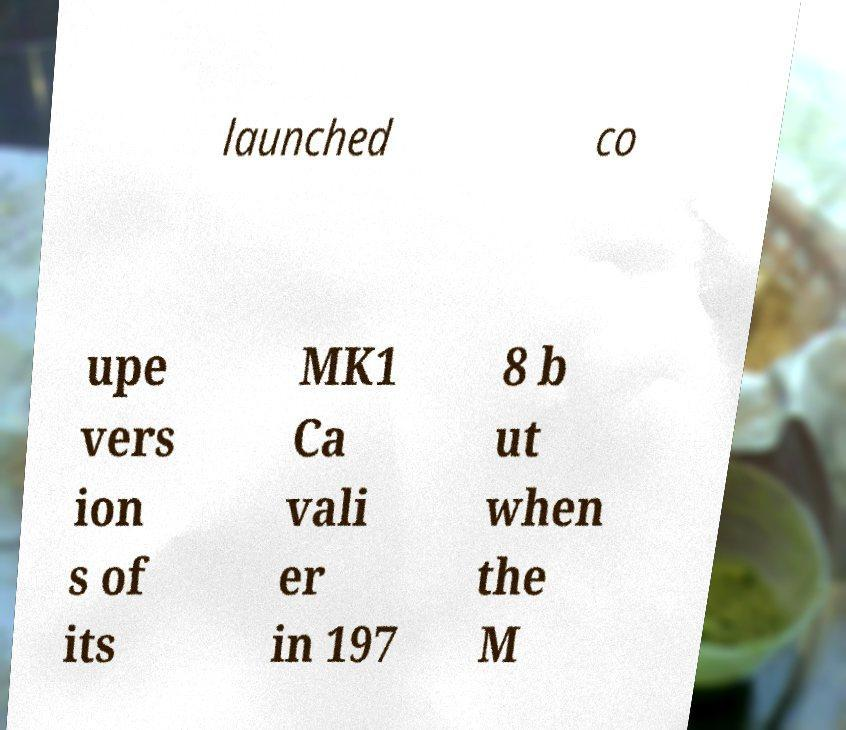Could you assist in decoding the text presented in this image and type it out clearly? launched co upe vers ion s of its MK1 Ca vali er in 197 8 b ut when the M 